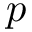Convert formula to latex. <formula><loc_0><loc_0><loc_500><loc_500>p</formula> 